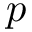Convert formula to latex. <formula><loc_0><loc_0><loc_500><loc_500>p</formula> 